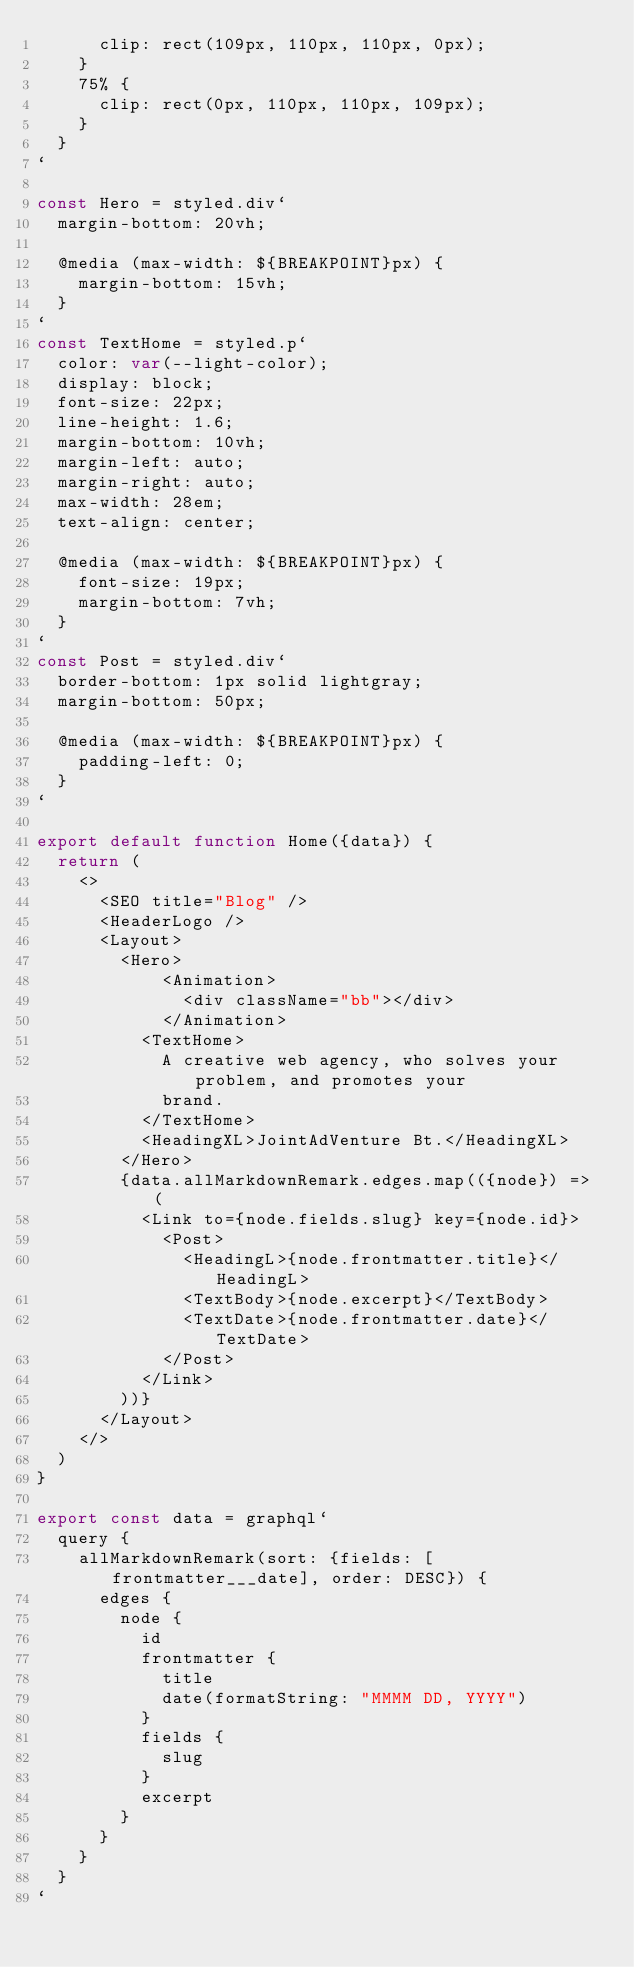<code> <loc_0><loc_0><loc_500><loc_500><_JavaScript_>      clip: rect(109px, 110px, 110px, 0px);
    }
    75% {
      clip: rect(0px, 110px, 110px, 109px);
    }
  }
`

const Hero = styled.div`
  margin-bottom: 20vh;

  @media (max-width: ${BREAKPOINT}px) {
    margin-bottom: 15vh;
  }
`
const TextHome = styled.p`
  color: var(--light-color);
  display: block;
  font-size: 22px;
  line-height: 1.6;
  margin-bottom: 10vh;
  margin-left: auto;
  margin-right: auto;
  max-width: 28em;
  text-align: center;

  @media (max-width: ${BREAKPOINT}px) {
    font-size: 19px;
    margin-bottom: 7vh;
  }
`
const Post = styled.div`
  border-bottom: 1px solid lightgray;
  margin-bottom: 50px;

  @media (max-width: ${BREAKPOINT}px) {
    padding-left: 0;
  }
`

export default function Home({data}) {
  return (
    <>
      <SEO title="Blog" />
      <HeaderLogo />
      <Layout>
        <Hero>
            <Animation>
              <div className="bb"></div>
            </Animation>
          <TextHome>
            A creative web agency, who solves your problem, and promotes your
            brand.
          </TextHome>
          <HeadingXL>JointAdVenture Bt.</HeadingXL>
        </Hero>
        {data.allMarkdownRemark.edges.map(({node}) => (
          <Link to={node.fields.slug} key={node.id}>
            <Post>
              <HeadingL>{node.frontmatter.title}</HeadingL>
              <TextBody>{node.excerpt}</TextBody>
              <TextDate>{node.frontmatter.date}</TextDate>
            </Post>
          </Link>
        ))}
      </Layout>
    </>
  )
}

export const data = graphql`
  query {
    allMarkdownRemark(sort: {fields: [frontmatter___date], order: DESC}) {
      edges {
        node {
          id
          frontmatter {
            title
            date(formatString: "MMMM DD, YYYY")
          }
          fields {
            slug
          }
          excerpt
        }
      }
    }
  }
`
</code> 